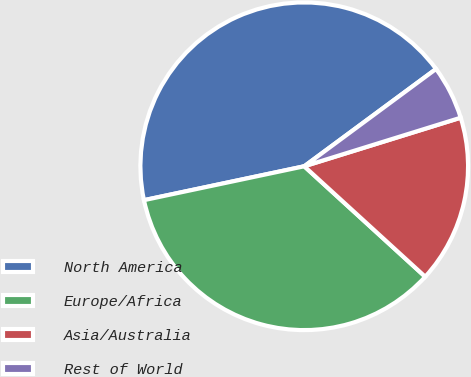Convert chart. <chart><loc_0><loc_0><loc_500><loc_500><pie_chart><fcel>North America<fcel>Europe/Africa<fcel>Asia/Australia<fcel>Rest of World<nl><fcel>43.2%<fcel>34.91%<fcel>16.57%<fcel>5.33%<nl></chart> 